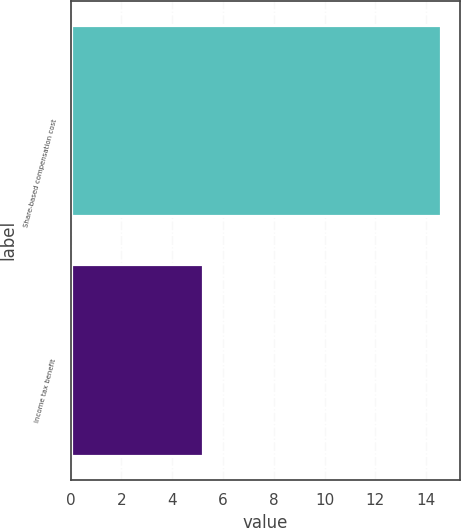<chart> <loc_0><loc_0><loc_500><loc_500><bar_chart><fcel>Share-based compensation cost<fcel>Income tax benefit<nl><fcel>14.6<fcel>5.2<nl></chart> 